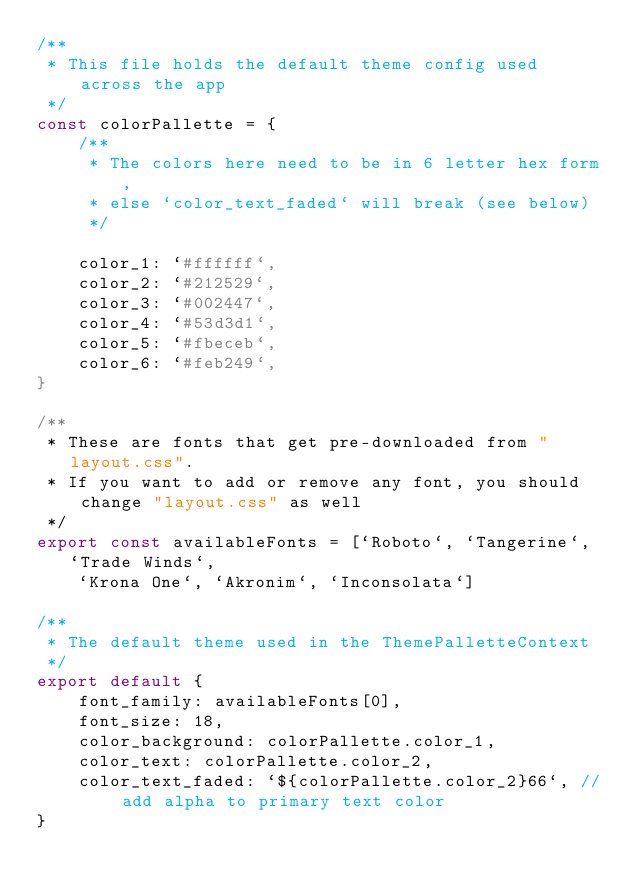<code> <loc_0><loc_0><loc_500><loc_500><_JavaScript_>/**
 * This file holds the default theme config used across the app
 */
const colorPallette = {
    /**
     * The colors here need to be in 6 letter hex form,
     * else `color_text_faded` will break (see below)
     */

    color_1: `#ffffff`,
    color_2: `#212529`,
    color_3: `#002447`,
    color_4: `#53d3d1`,
    color_5: `#fbeceb`,
    color_6: `#feb249`,
}

/** 
 * These are fonts that get pre-downloaded from "layout.css".
 * If you want to add or remove any font, you should change "layout.css" as well
 */
export const availableFonts = [`Roboto`, `Tangerine`, `Trade Winds`,
    `Krona One`, `Akronim`, `Inconsolata`]
    
/**
 * The default theme used in the ThemePalletteContext
 */
export default {
    font_family: availableFonts[0],
    font_size: 18,
    color_background: colorPallette.color_1,
    color_text: colorPallette.color_2,
    color_text_faded: `${colorPallette.color_2}66`, // add alpha to primary text color
}</code> 